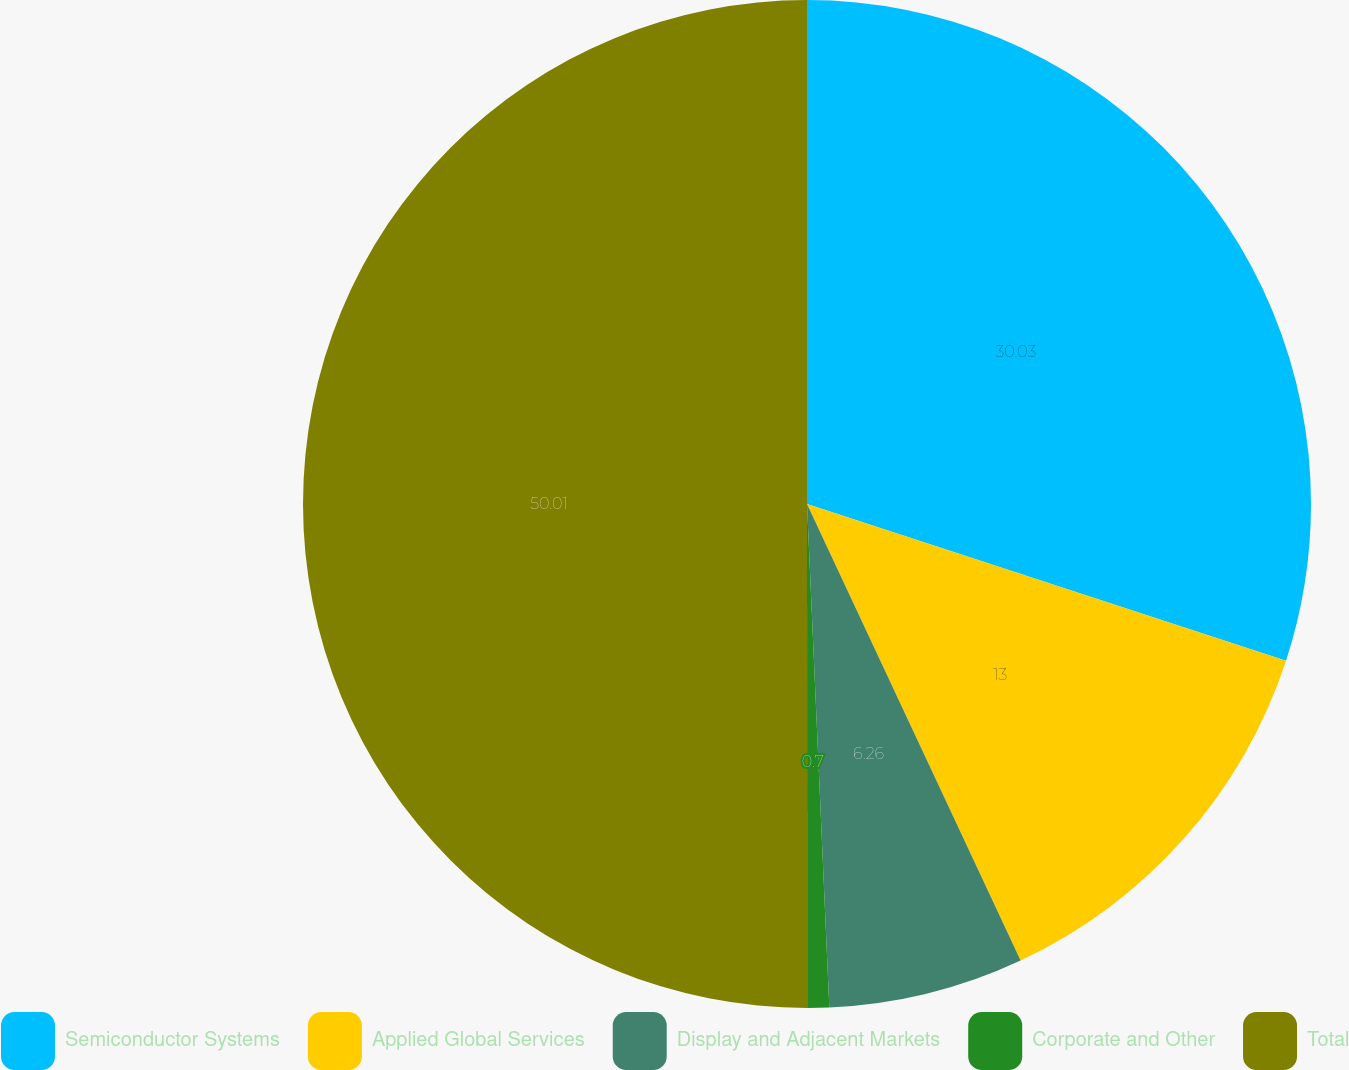<chart> <loc_0><loc_0><loc_500><loc_500><pie_chart><fcel>Semiconductor Systems<fcel>Applied Global Services<fcel>Display and Adjacent Markets<fcel>Corporate and Other<fcel>Total<nl><fcel>30.03%<fcel>13.0%<fcel>6.26%<fcel>0.7%<fcel>50.0%<nl></chart> 